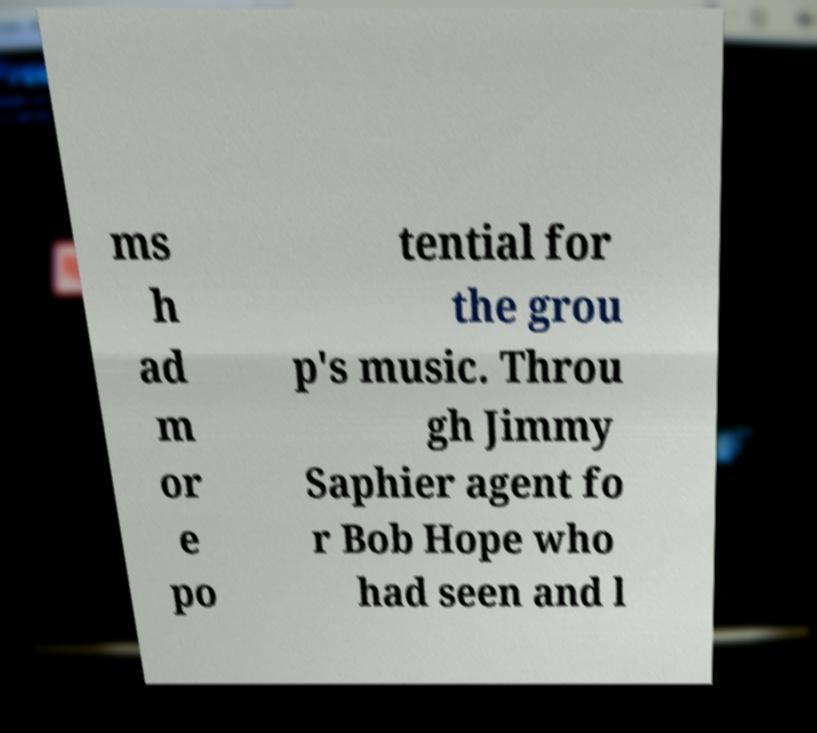Please identify and transcribe the text found in this image. ms h ad m or e po tential for the grou p's music. Throu gh Jimmy Saphier agent fo r Bob Hope who had seen and l 